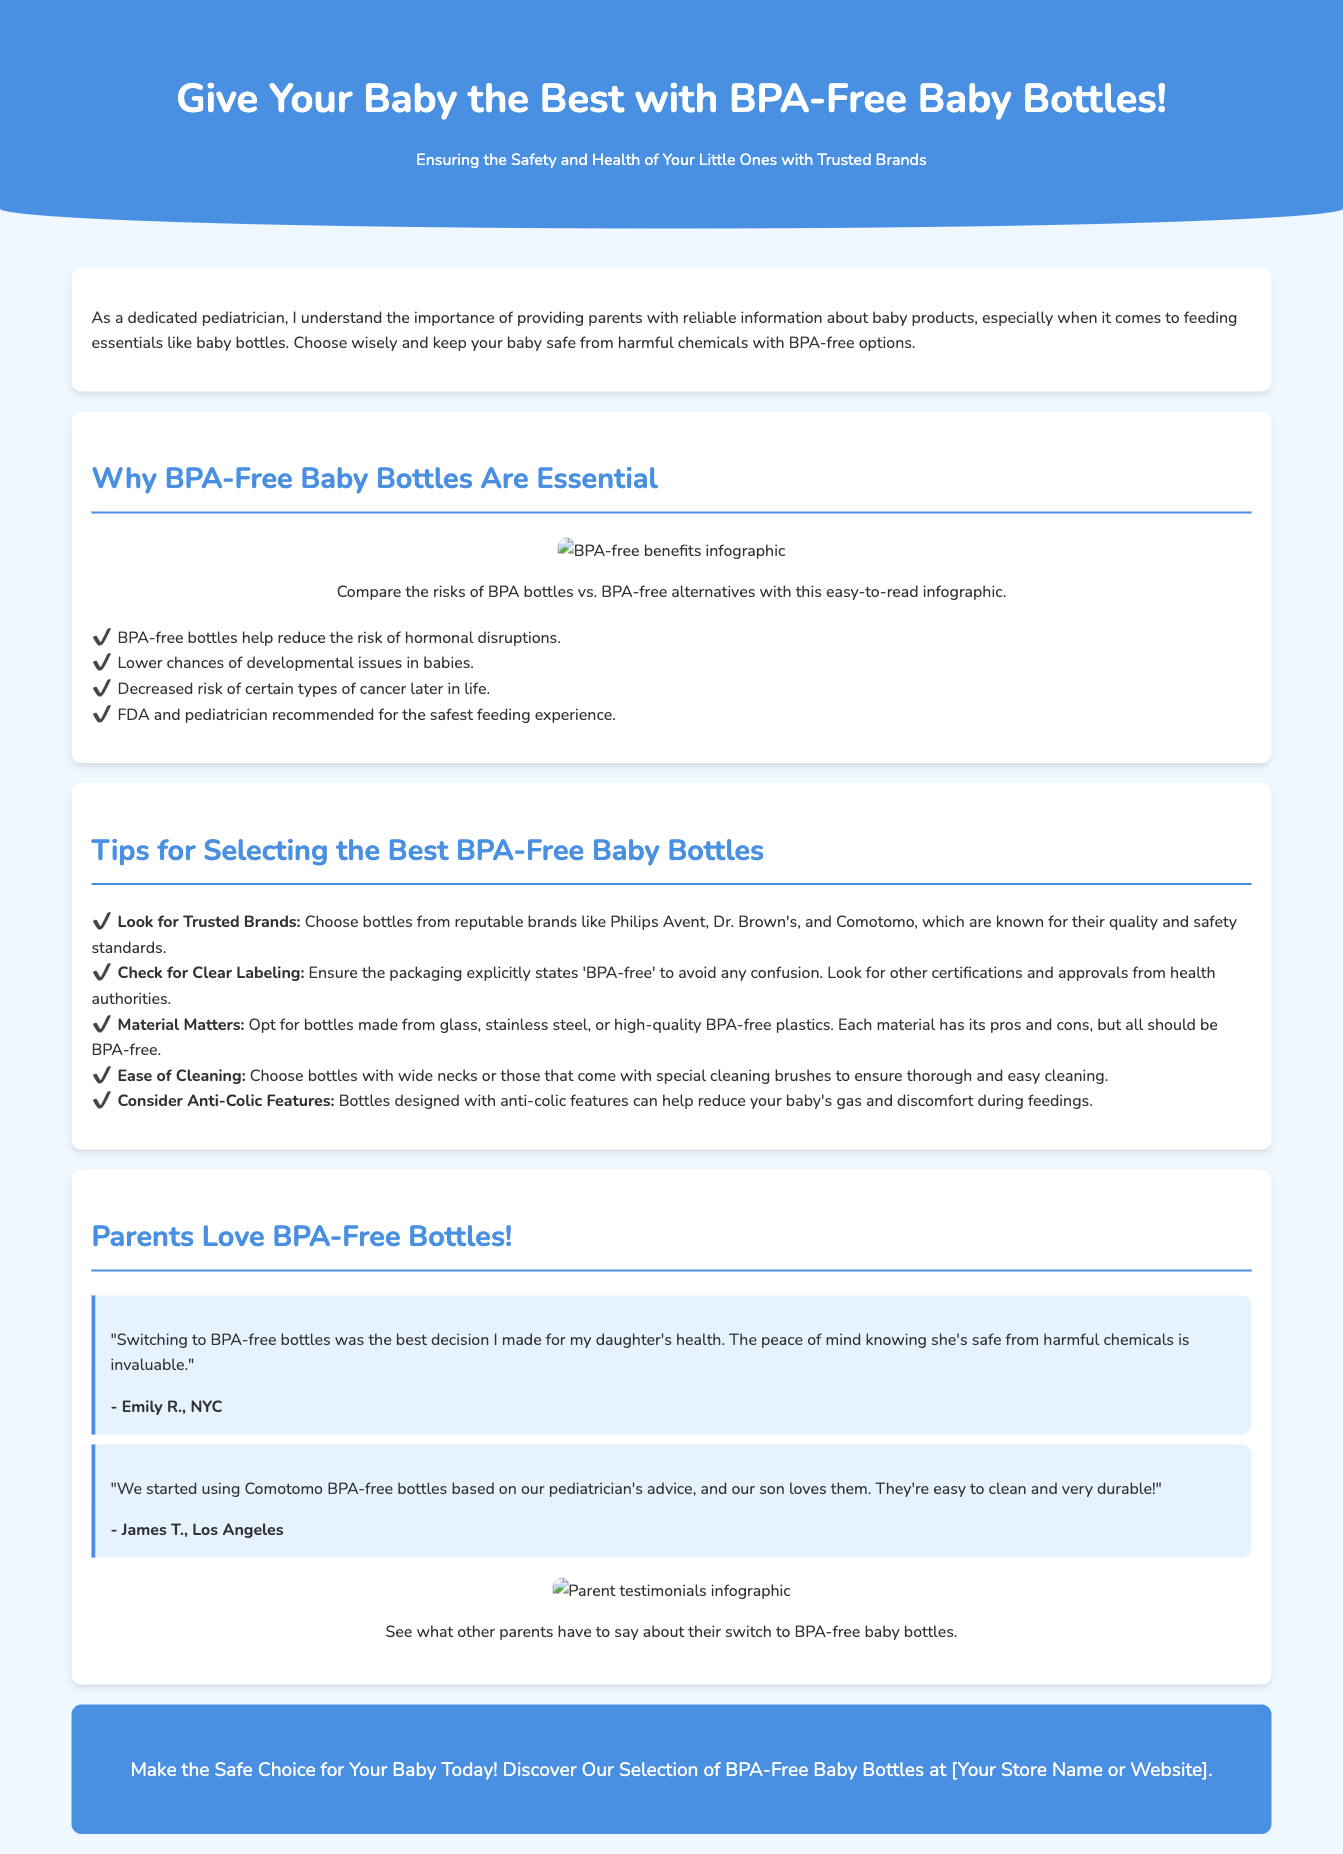What is the title of the advertisement? The title of the advertisement is stated in the document's header section, which promotes BPA-Free Baby Bottles.
Answer: BPA-Free Baby Bottles: The Safe Choice for Your Little One Who recommends BPA-free bottles according to the document? The document mentions endorsements from a specific health authority and individuals in pediatric roles.
Answer: FDA and pediatrician Which brands are suggested for BPA-free baby bottles? The document lists specific trusted brands recommended for BPA-free baby bottles.
Answer: Philips Avent, Dr. Brown's, Comotomo What type of materials should be chosen for baby bottles? The advertisement emphasizes that certain materials are recommended for safety, particularly their BPA-free status.
Answer: Glass, stainless steel, or high-quality BPA-free plastics What is one benefit of using BPA-free bottles? The document outlines several benefits that BPA-free bottles offer to infants regarding safety and health.
Answer: Reduce the risk of hormonal disruptions What is the major concern addressed in this advertisement? The primary concern highlighted in the advertisement focuses on a specific chemical found in baby bottles and its health implications.
Answer: Harmful chemicals (BPA) How do parents feel about BPA-free bottles based on testimonials? The testimonials provide personal insights from parents about their experiences with BPA-free bottles.
Answer: Positive (peace of mind, love them) What cleaning feature should parents consider when selecting baby bottles? The document gives specific advice about what cleaning capabilities are ideal in baby bottles.
Answer: Ease of cleaning What call to action is included in the advertisement? The advertisement concludes with an encouragement for viewers to make a specific purchase.
Answer: Discover Our Selection of BPA-Free Baby Bottles at [Your Store Name or Website] 